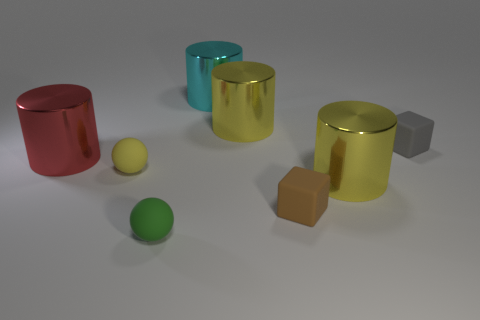Subtract all cyan metallic cylinders. How many cylinders are left? 3 Add 2 yellow metallic objects. How many objects exist? 10 Subtract all red cylinders. How many cylinders are left? 3 Subtract all balls. How many objects are left? 6 Subtract 2 cubes. How many cubes are left? 0 Subtract 0 green cylinders. How many objects are left? 8 Subtract all gray blocks. Subtract all blue cylinders. How many blocks are left? 1 Subtract all purple cylinders. How many blue balls are left? 0 Subtract all big yellow metal cylinders. Subtract all tiny gray matte objects. How many objects are left? 5 Add 4 big red metallic cylinders. How many big red metallic cylinders are left? 5 